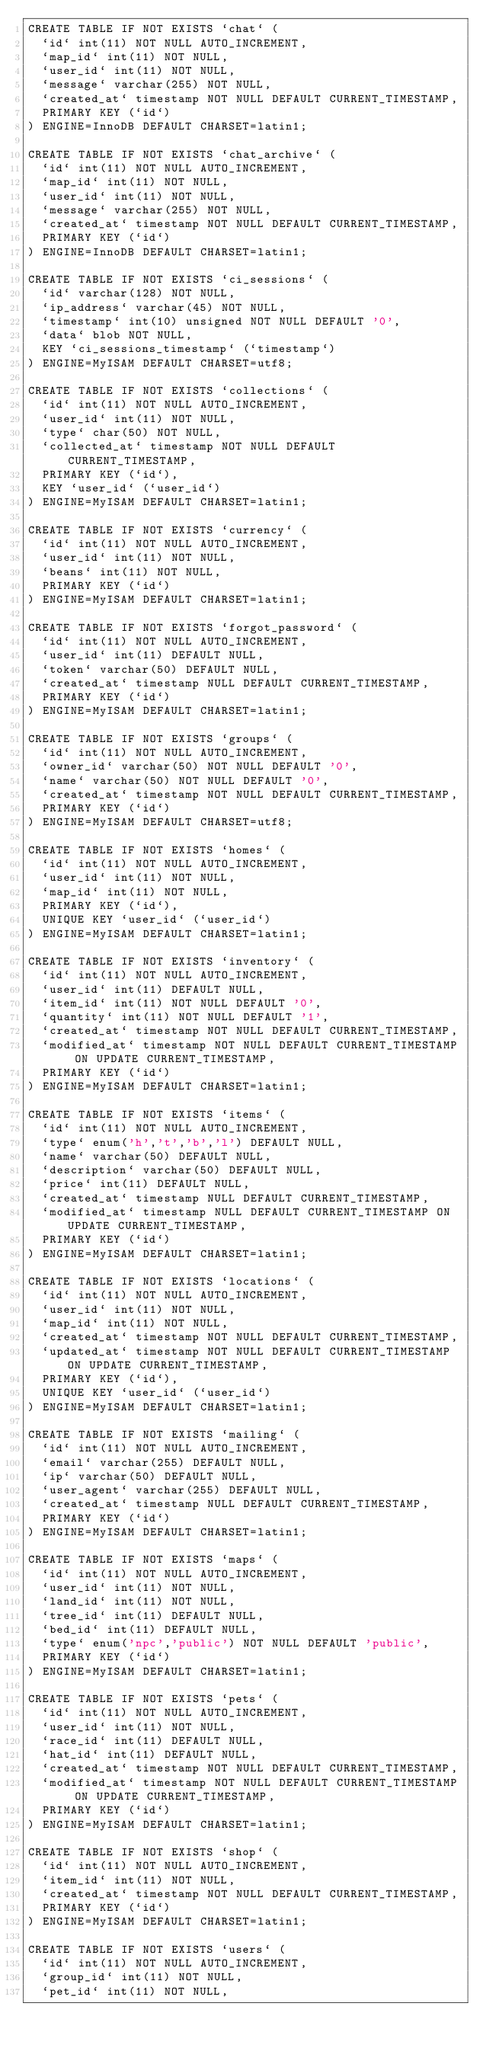Convert code to text. <code><loc_0><loc_0><loc_500><loc_500><_SQL_>CREATE TABLE IF NOT EXISTS `chat` (
  `id` int(11) NOT NULL AUTO_INCREMENT,
  `map_id` int(11) NOT NULL,
  `user_id` int(11) NOT NULL,
  `message` varchar(255) NOT NULL,
  `created_at` timestamp NOT NULL DEFAULT CURRENT_TIMESTAMP,
  PRIMARY KEY (`id`)
) ENGINE=InnoDB DEFAULT CHARSET=latin1;

CREATE TABLE IF NOT EXISTS `chat_archive` (
  `id` int(11) NOT NULL AUTO_INCREMENT,
  `map_id` int(11) NOT NULL,
  `user_id` int(11) NOT NULL,
  `message` varchar(255) NOT NULL,
  `created_at` timestamp NOT NULL DEFAULT CURRENT_TIMESTAMP,
  PRIMARY KEY (`id`)
) ENGINE=InnoDB DEFAULT CHARSET=latin1;

CREATE TABLE IF NOT EXISTS `ci_sessions` (
  `id` varchar(128) NOT NULL,
  `ip_address` varchar(45) NOT NULL,
  `timestamp` int(10) unsigned NOT NULL DEFAULT '0',
  `data` blob NOT NULL,
  KEY `ci_sessions_timestamp` (`timestamp`)
) ENGINE=MyISAM DEFAULT CHARSET=utf8;

CREATE TABLE IF NOT EXISTS `collections` (
  `id` int(11) NOT NULL AUTO_INCREMENT,
  `user_id` int(11) NOT NULL,
  `type` char(50) NOT NULL,
  `collected_at` timestamp NOT NULL DEFAULT CURRENT_TIMESTAMP,
  PRIMARY KEY (`id`),
  KEY `user_id` (`user_id`)
) ENGINE=MyISAM DEFAULT CHARSET=latin1;

CREATE TABLE IF NOT EXISTS `currency` (
  `id` int(11) NOT NULL AUTO_INCREMENT,
  `user_id` int(11) NOT NULL,
  `beans` int(11) NOT NULL,
  PRIMARY KEY (`id`)
) ENGINE=MyISAM DEFAULT CHARSET=latin1;

CREATE TABLE IF NOT EXISTS `forgot_password` (
  `id` int(11) NOT NULL AUTO_INCREMENT,
  `user_id` int(11) DEFAULT NULL,
  `token` varchar(50) DEFAULT NULL,
  `created_at` timestamp NULL DEFAULT CURRENT_TIMESTAMP,
  PRIMARY KEY (`id`)
) ENGINE=MyISAM DEFAULT CHARSET=latin1;

CREATE TABLE IF NOT EXISTS `groups` (
  `id` int(11) NOT NULL AUTO_INCREMENT,
  `owner_id` varchar(50) NOT NULL DEFAULT '0',
  `name` varchar(50) NOT NULL DEFAULT '0',
  `created_at` timestamp NOT NULL DEFAULT CURRENT_TIMESTAMP,
  PRIMARY KEY (`id`)
) ENGINE=MyISAM DEFAULT CHARSET=utf8;

CREATE TABLE IF NOT EXISTS `homes` (
  `id` int(11) NOT NULL AUTO_INCREMENT,
  `user_id` int(11) NOT NULL,
  `map_id` int(11) NOT NULL,
  PRIMARY KEY (`id`),
  UNIQUE KEY `user_id` (`user_id`)
) ENGINE=MyISAM DEFAULT CHARSET=latin1;

CREATE TABLE IF NOT EXISTS `inventory` (
  `id` int(11) NOT NULL AUTO_INCREMENT,
  `user_id` int(11) DEFAULT NULL,
  `item_id` int(11) NOT NULL DEFAULT '0',
  `quantity` int(11) NOT NULL DEFAULT '1',
  `created_at` timestamp NOT NULL DEFAULT CURRENT_TIMESTAMP,
  `modified_at` timestamp NOT NULL DEFAULT CURRENT_TIMESTAMP ON UPDATE CURRENT_TIMESTAMP,
  PRIMARY KEY (`id`)
) ENGINE=MyISAM DEFAULT CHARSET=latin1;

CREATE TABLE IF NOT EXISTS `items` (
  `id` int(11) NOT NULL AUTO_INCREMENT,
  `type` enum('h','t','b','l') DEFAULT NULL,
  `name` varchar(50) DEFAULT NULL,
  `description` varchar(50) DEFAULT NULL,
  `price` int(11) DEFAULT NULL,
  `created_at` timestamp NULL DEFAULT CURRENT_TIMESTAMP,
  `modified_at` timestamp NULL DEFAULT CURRENT_TIMESTAMP ON UPDATE CURRENT_TIMESTAMP,
  PRIMARY KEY (`id`)
) ENGINE=MyISAM DEFAULT CHARSET=latin1;

CREATE TABLE IF NOT EXISTS `locations` (
  `id` int(11) NOT NULL AUTO_INCREMENT,
  `user_id` int(11) NOT NULL,
  `map_id` int(11) NOT NULL,
  `created_at` timestamp NOT NULL DEFAULT CURRENT_TIMESTAMP,
  `updated_at` timestamp NOT NULL DEFAULT CURRENT_TIMESTAMP ON UPDATE CURRENT_TIMESTAMP,
  PRIMARY KEY (`id`),
  UNIQUE KEY `user_id` (`user_id`)
) ENGINE=MyISAM DEFAULT CHARSET=latin1;

CREATE TABLE IF NOT EXISTS `mailing` (
  `id` int(11) NOT NULL AUTO_INCREMENT,
  `email` varchar(255) DEFAULT NULL,
  `ip` varchar(50) DEFAULT NULL,
  `user_agent` varchar(255) DEFAULT NULL,
  `created_at` timestamp NULL DEFAULT CURRENT_TIMESTAMP,
  PRIMARY KEY (`id`)
) ENGINE=MyISAM DEFAULT CHARSET=latin1;

CREATE TABLE IF NOT EXISTS `maps` (
  `id` int(11) NOT NULL AUTO_INCREMENT,
  `user_id` int(11) NOT NULL,
  `land_id` int(11) NOT NULL,
  `tree_id` int(11) DEFAULT NULL,
  `bed_id` int(11) DEFAULT NULL,
  `type` enum('npc','public') NOT NULL DEFAULT 'public',
  PRIMARY KEY (`id`)
) ENGINE=MyISAM DEFAULT CHARSET=latin1;

CREATE TABLE IF NOT EXISTS `pets` (
  `id` int(11) NOT NULL AUTO_INCREMENT,
  `user_id` int(11) NOT NULL,
  `race_id` int(11) DEFAULT NULL,
  `hat_id` int(11) DEFAULT NULL,
  `created_at` timestamp NOT NULL DEFAULT CURRENT_TIMESTAMP,
  `modified_at` timestamp NOT NULL DEFAULT CURRENT_TIMESTAMP ON UPDATE CURRENT_TIMESTAMP,
  PRIMARY KEY (`id`)
) ENGINE=MyISAM DEFAULT CHARSET=latin1;

CREATE TABLE IF NOT EXISTS `shop` (
  `id` int(11) NOT NULL AUTO_INCREMENT,
  `item_id` int(11) NOT NULL,
  `created_at` timestamp NOT NULL DEFAULT CURRENT_TIMESTAMP,
  PRIMARY KEY (`id`)
) ENGINE=MyISAM DEFAULT CHARSET=latin1;

CREATE TABLE IF NOT EXISTS `users` (
  `id` int(11) NOT NULL AUTO_INCREMENT,
  `group_id` int(11) NOT NULL,
  `pet_id` int(11) NOT NULL,</code> 